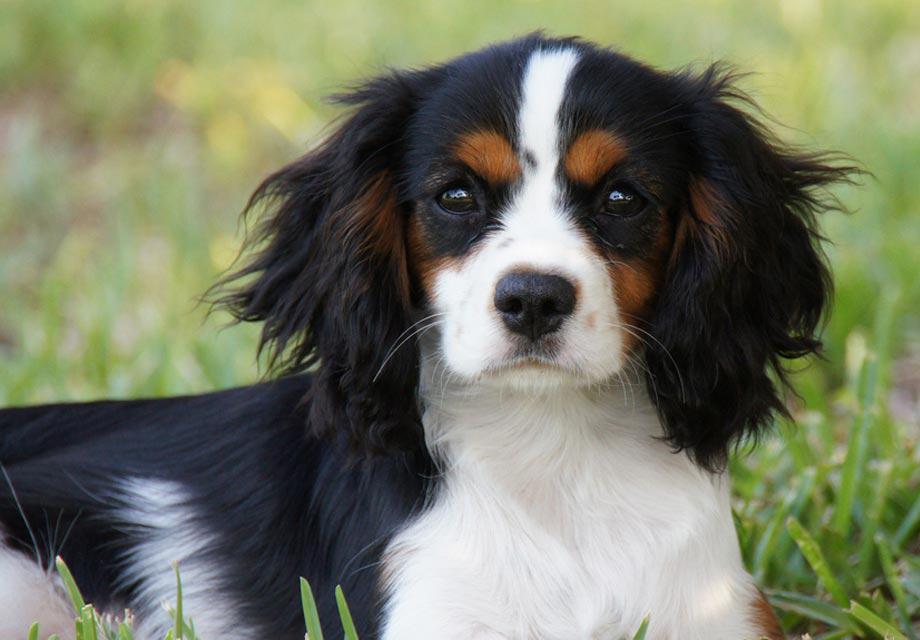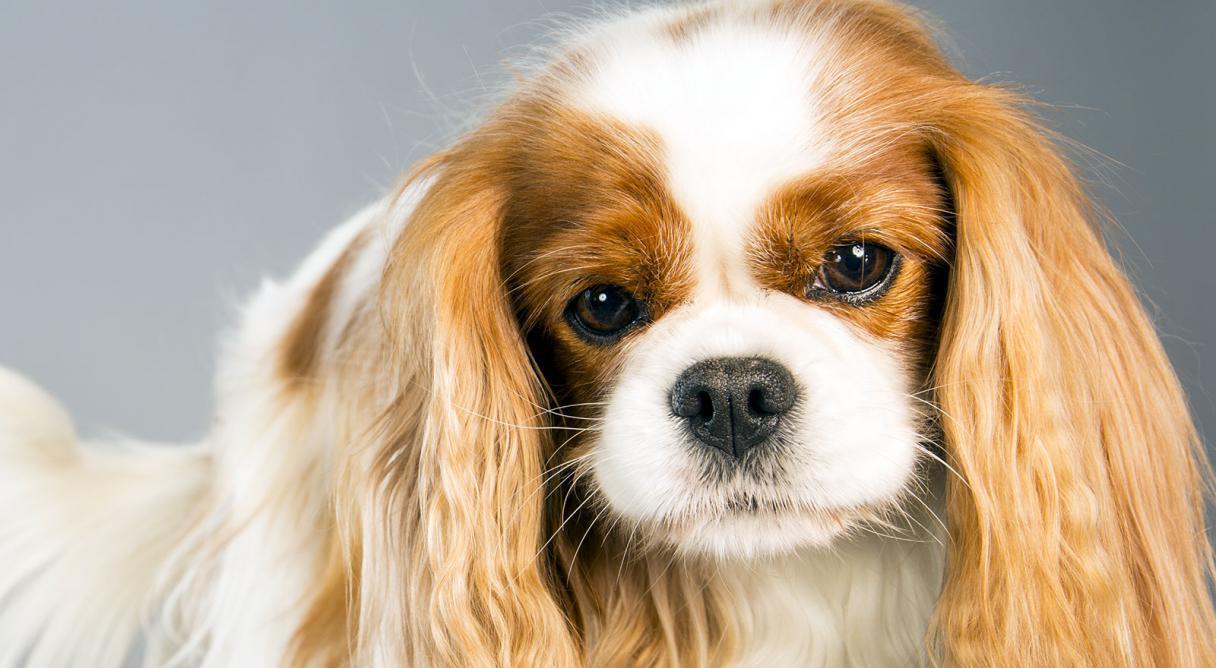The first image is the image on the left, the second image is the image on the right. For the images displayed, is the sentence "Each image contains exactly one spaniel, and only the dog on the right is posed on real grass." factually correct? Answer yes or no. No. The first image is the image on the left, the second image is the image on the right. Examine the images to the left and right. Is the description "2 dogs exactly can be seen and they are both facing the same way." accurate? Answer yes or no. Yes. 